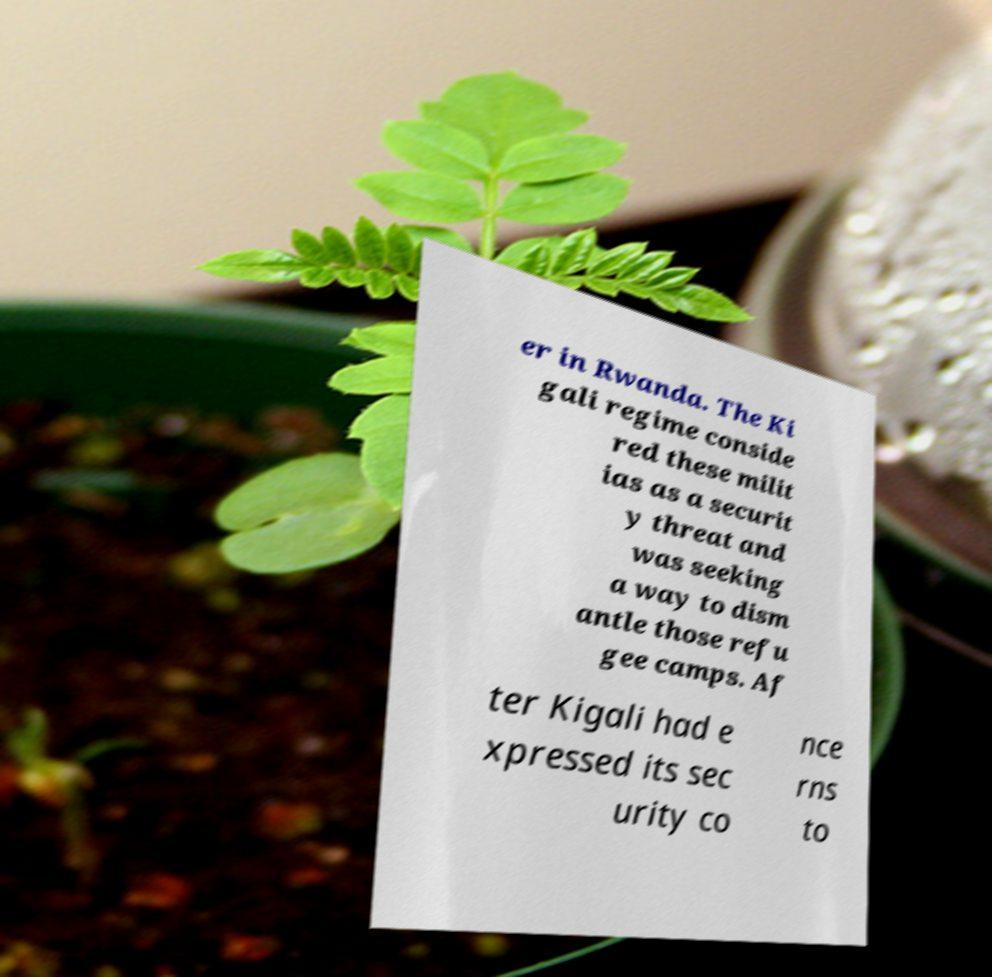Could you assist in decoding the text presented in this image and type it out clearly? er in Rwanda. The Ki gali regime conside red these milit ias as a securit y threat and was seeking a way to dism antle those refu gee camps. Af ter Kigali had e xpressed its sec urity co nce rns to 